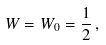Convert formula to latex. <formula><loc_0><loc_0><loc_500><loc_500>W = W _ { 0 } = \frac { 1 } { 2 } \, ,</formula> 